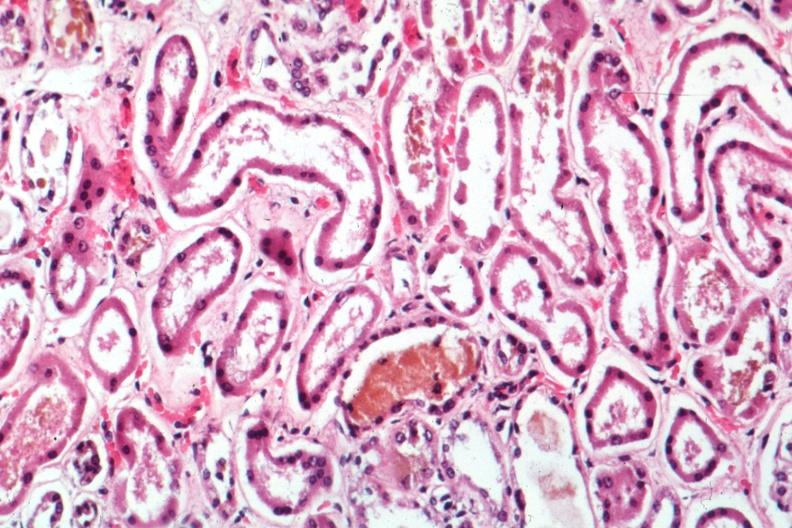s kidney present?
Answer the question using a single word or phrase. Yes 